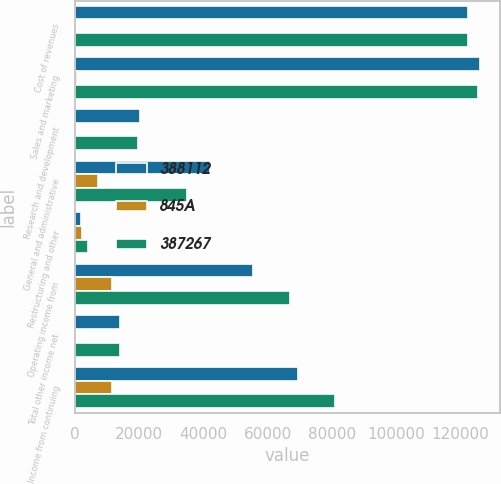Convert chart. <chart><loc_0><loc_0><loc_500><loc_500><stacked_bar_chart><ecel><fcel>Cost of revenues<fcel>Sales and marketing<fcel>Research and development<fcel>General and administrative<fcel>Restructuring and other<fcel>Operating income from<fcel>Total other income net<fcel>Income from continuing<nl><fcel>388112<fcel>122388<fcel>126181<fcel>20199<fcel>42099<fcel>1875<fcel>55435<fcel>14149<fcel>69584<nl><fcel>845A<fcel>22<fcel>678<fcel>457<fcel>7304<fcel>2350<fcel>11656<fcel>174<fcel>11482<nl><fcel>387267<fcel>122366<fcel>125503<fcel>19742<fcel>34795<fcel>4225<fcel>67091<fcel>13975<fcel>81066<nl></chart> 